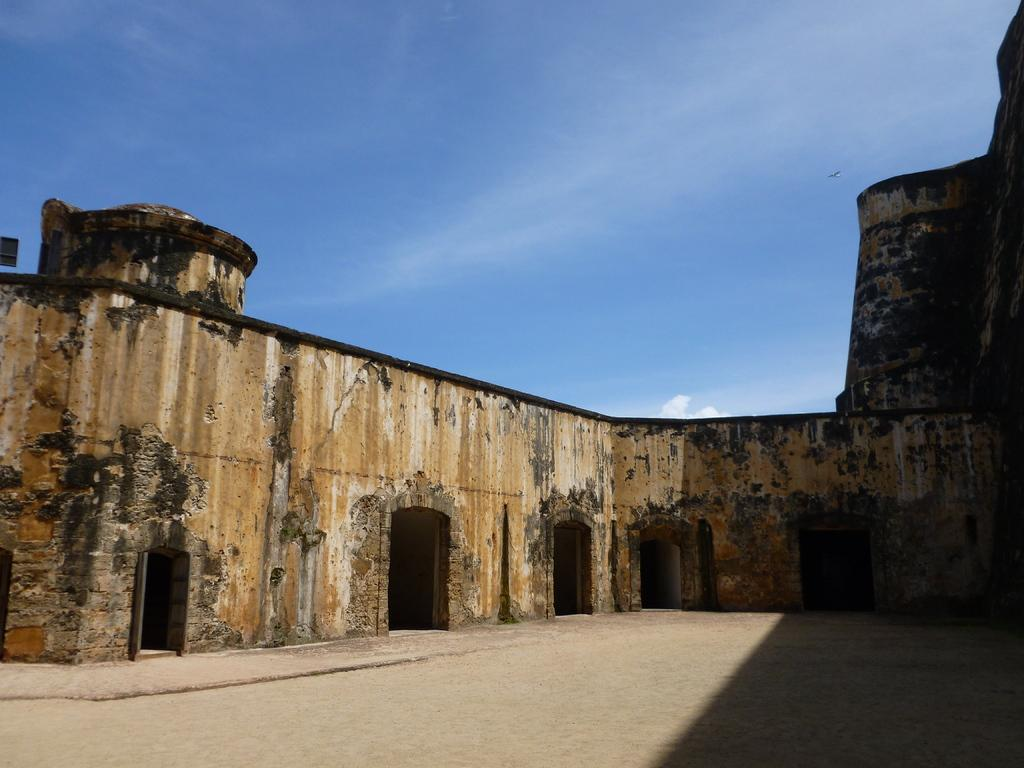What type of wall is visible in the image? The wall has a brick pattern. Where is the brick wall located in the image? The brick wall is in the right corner of the image. What color is the sky in the image? The sky is blue in color. How many snails can be seen crawling on the brick wall in the image? There are no snails visible on the brick wall in the image. What type of gardening tool is present in the image? There is no gardening tool, such as a spade, present in the image. 